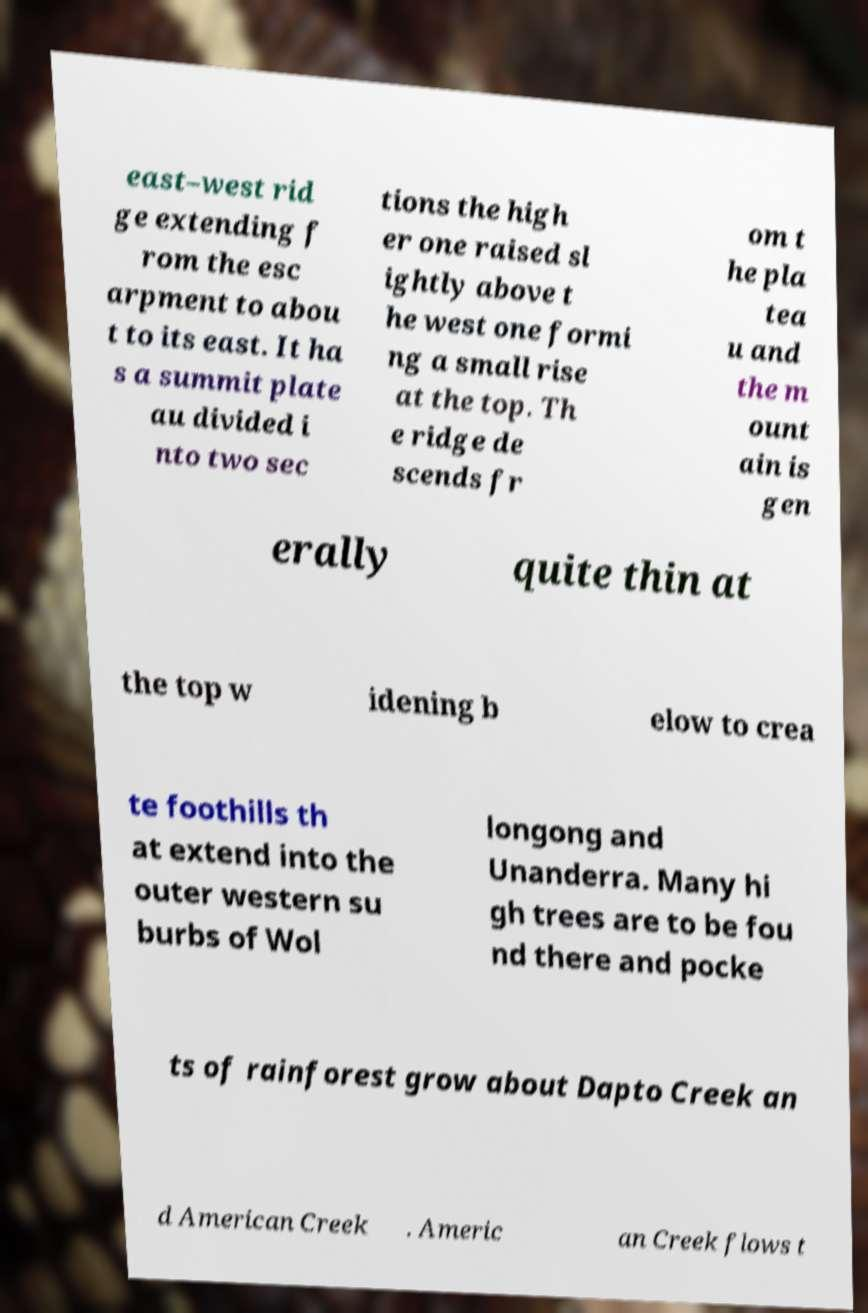For documentation purposes, I need the text within this image transcribed. Could you provide that? east–west rid ge extending f rom the esc arpment to abou t to its east. It ha s a summit plate au divided i nto two sec tions the high er one raised sl ightly above t he west one formi ng a small rise at the top. Th e ridge de scends fr om t he pla tea u and the m ount ain is gen erally quite thin at the top w idening b elow to crea te foothills th at extend into the outer western su burbs of Wol longong and Unanderra. Many hi gh trees are to be fou nd there and pocke ts of rainforest grow about Dapto Creek an d American Creek . Americ an Creek flows t 